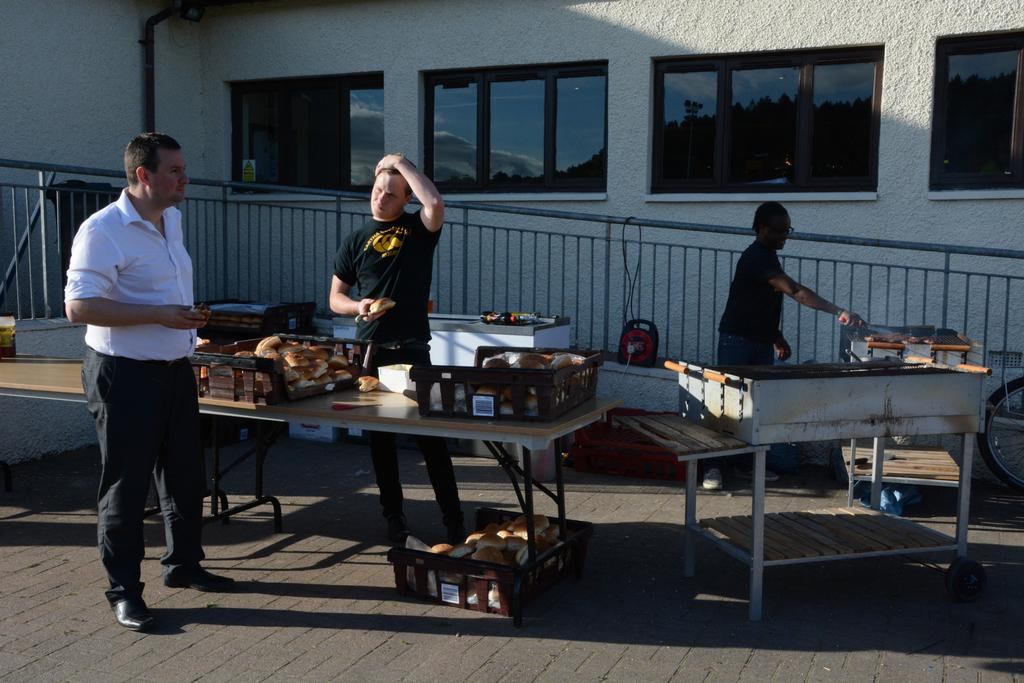What is one of the main features of the image? There is a wall in the image. How many people are present in the image? There are three people in the image. What piece of furniture can be seen in the image? There is a table in the image. What type of pets are visible in the image? There are no pets present in the image. What color is the pencil used by one of the people in the image? There is no pencil visible in the image. 